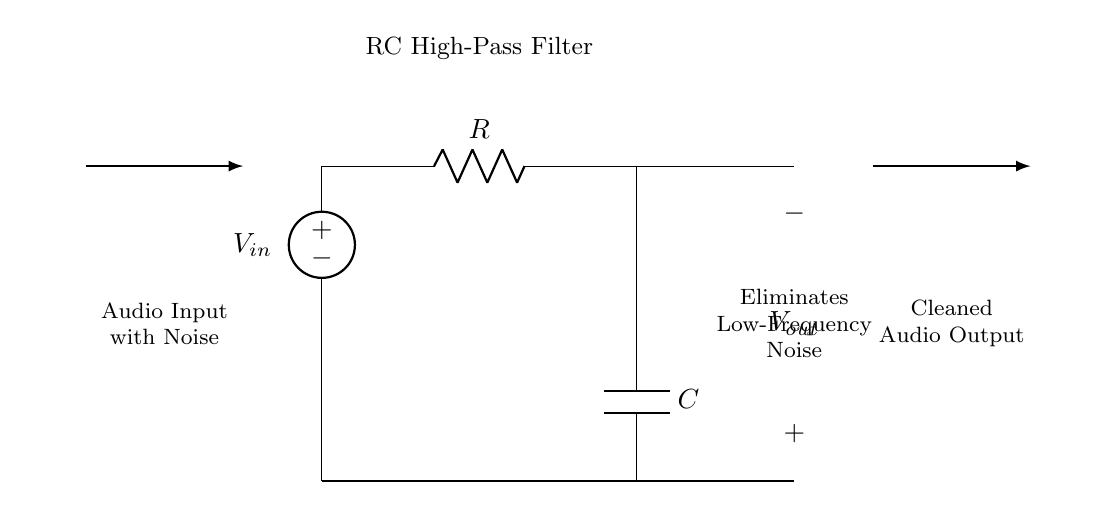What type of filter is represented by this circuit? The circuit is an RC high-pass filter, which is designed to allow high-frequency signals to pass while blocking low-frequency signals. The presence of both a resistor and a capacitor in this specific configuration indicates its functionality as a high-pass filter.
Answer: RC high-pass filter What is the purpose of the capacitor in this circuit? The capacitor serves to block low-frequency signals while allowing higher frequencies to pass through to the output. When low-frequency voltages are present, the capacitor charges up and effectively prevents these voltages from reaching the output, thus removing unwanted noise.
Answer: Block low-frequency signals What does Vout represent in the circuit? Vout represents the voltage output of the circuit after the high-pass filtering process has taken place. It is the clean audio output that has had low-frequency noise eliminated from the input signal.
Answer: Cleaned audio output What is connected to Vout in this circuit? Vout is connected to an open circuit, which implies it can send the filtered audio signal to subsequent audio processing equipment or to a recording device, where the cleaned signal can be utilized without the low-frequency noise.
Answer: Open circuit What happens to low-frequency signals in this circuit? Low-frequency signals are attenuated or eliminated by the high-pass filter. This occurs because the capacitor reacts to these signals, preventing them from passing through to the output, ensuring only higher frequencies are present in the output signal.
Answer: Eliminated What is the function of the resistor in the RC high-pass filter? The resistor works in conjunction with the capacitor to control the cutoff frequency of the filter. It helps define the rate at which the signal is attenuated, influencing how quickly low frequencies are blocked while allowing high frequencies to pass through.
Answer: Control cutoff frequency What is the input connection type for this circuit? The input connection for this circuit is specified as an audio source with noise, indicating that the circuit accepts audio signals that may contain low-frequency interference needing filtering.
Answer: Audio Input with Noise 